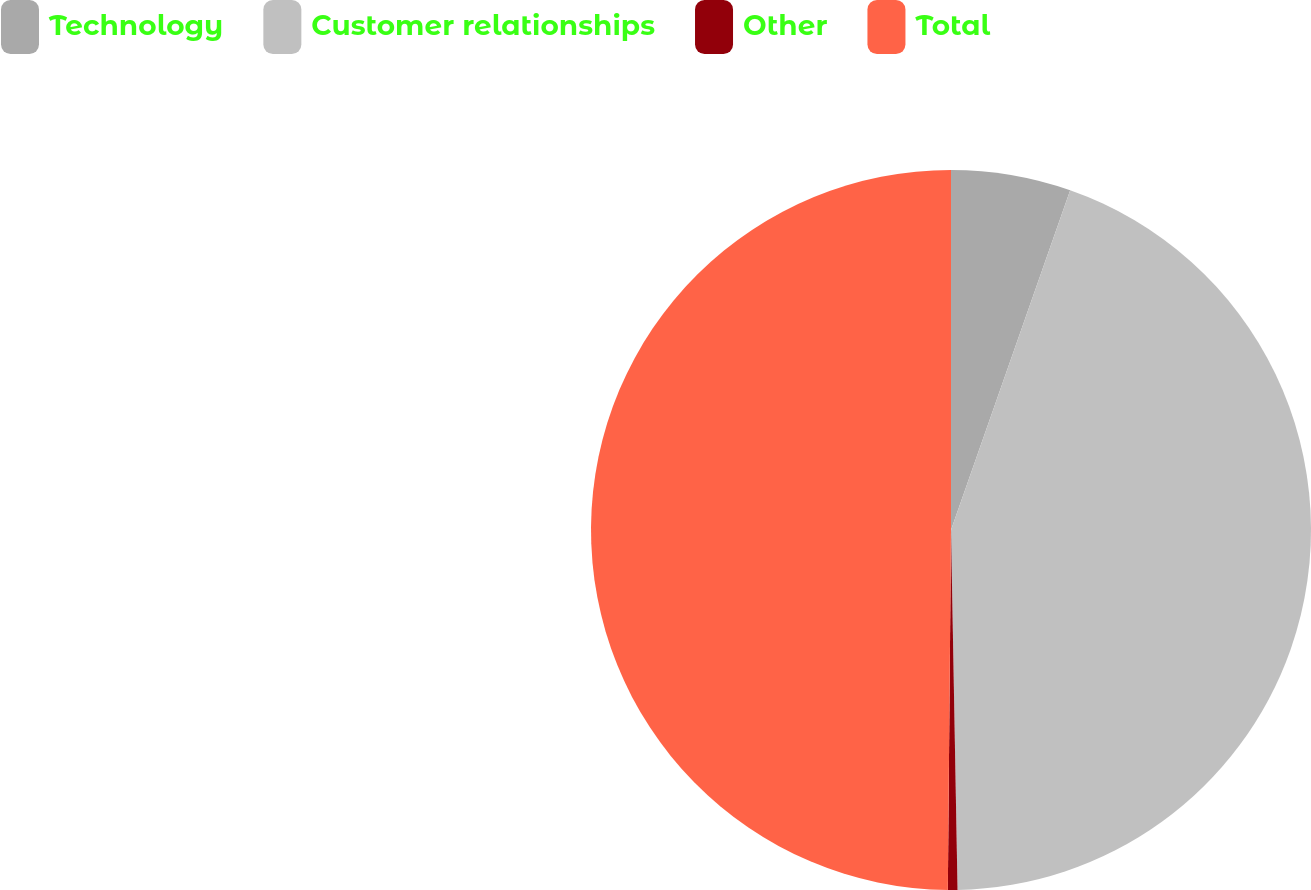Convert chart. <chart><loc_0><loc_0><loc_500><loc_500><pie_chart><fcel>Technology<fcel>Customer relationships<fcel>Other<fcel>Total<nl><fcel>5.37%<fcel>44.34%<fcel>0.43%<fcel>49.86%<nl></chart> 